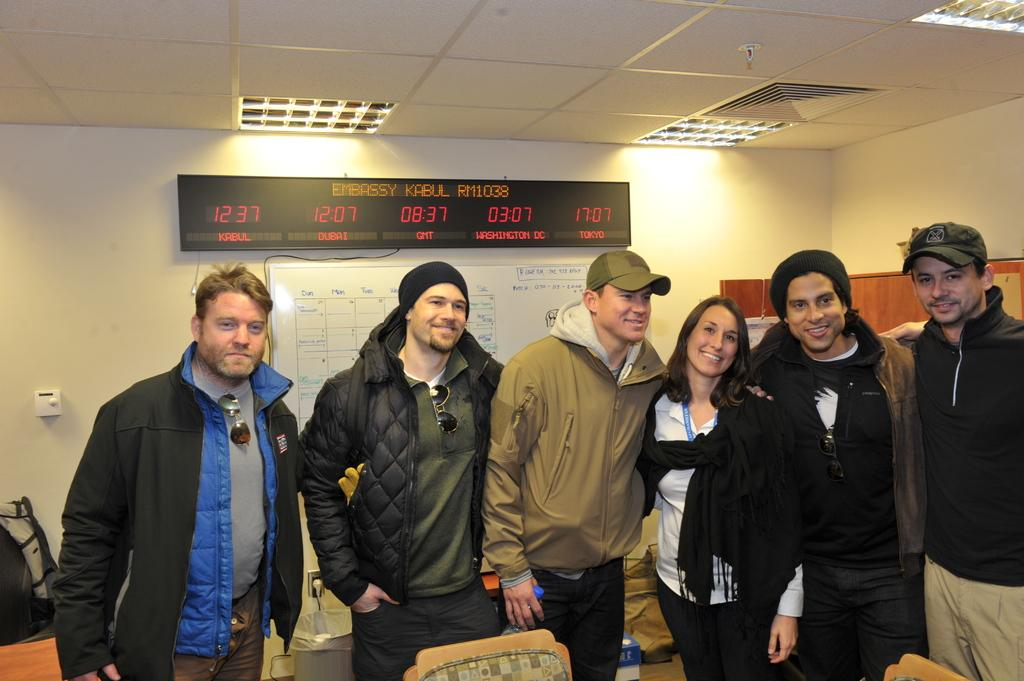What are the people in the image doing? The people in the image are standing in front of chairs. What else can be seen in the image besides the people and chairs? There are boards visible in the image. Are there any other structures or features in the image? Yes, there are lights on the roof in the image. How many pears are on the heads of the people in the image? There are no pears present on the heads of the people in the image. Are there any bears visible in the image? There are no bears visible in the image. 